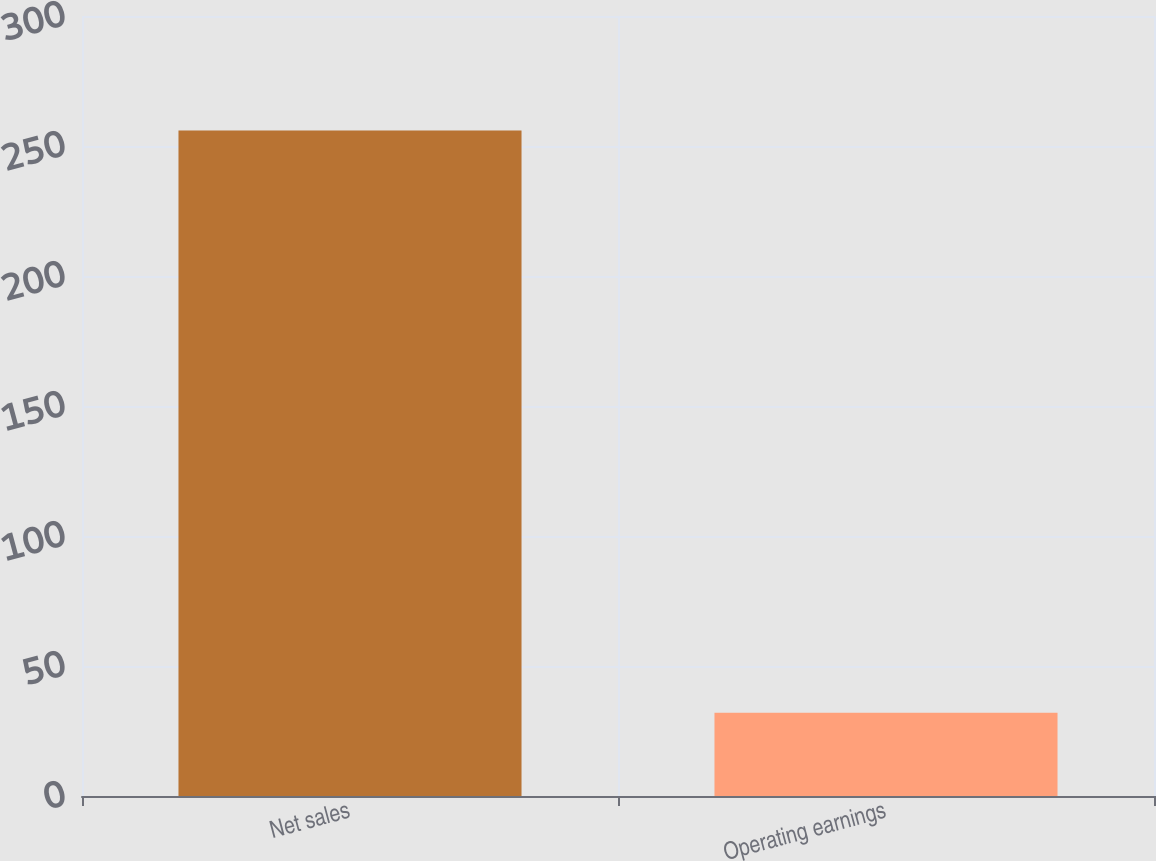Convert chart to OTSL. <chart><loc_0><loc_0><loc_500><loc_500><bar_chart><fcel>Net sales<fcel>Operating earnings<nl><fcel>256<fcel>32<nl></chart> 